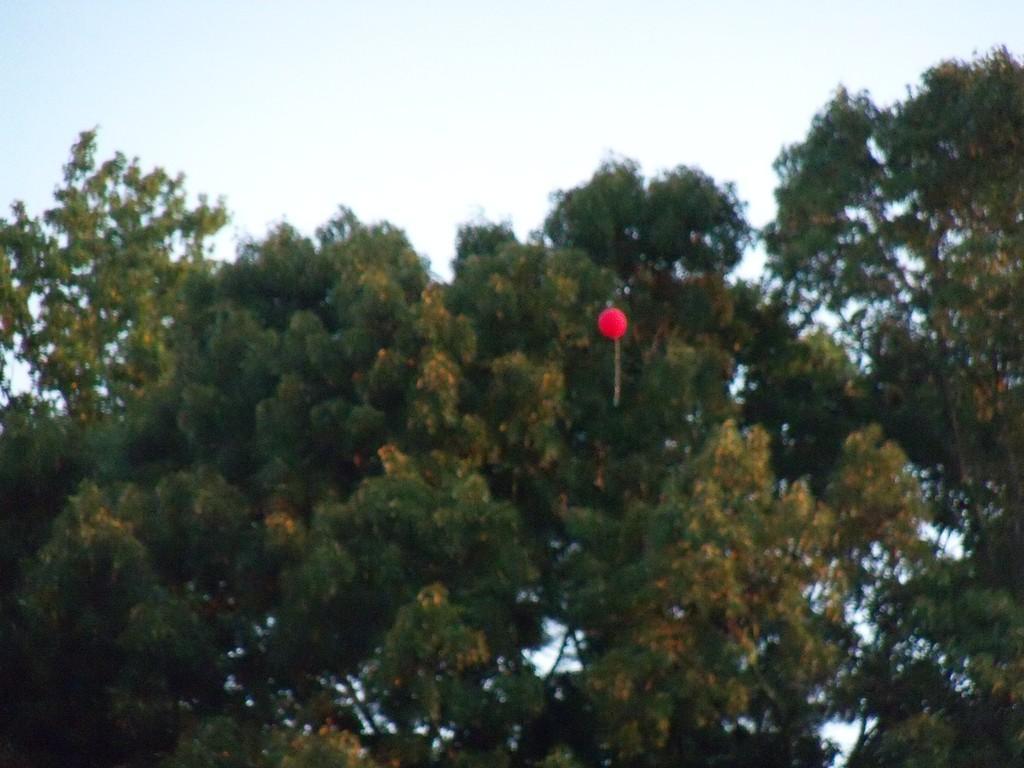Please provide a concise description of this image. In this image I see number of trees and I see a balloon over here which is of red color and I see the sky. 